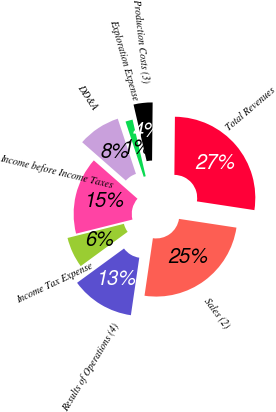Convert chart. <chart><loc_0><loc_0><loc_500><loc_500><pie_chart><fcel>Sales (2)<fcel>Total Revenues<fcel>Production Costs (3)<fcel>Exploration Expense<fcel>DD&A<fcel>Income before Income Taxes<fcel>Income Tax Expense<fcel>Results of Operations (4)<nl><fcel>24.9%<fcel>27.25%<fcel>3.78%<fcel>1.43%<fcel>8.47%<fcel>15.38%<fcel>6.13%<fcel>12.65%<nl></chart> 